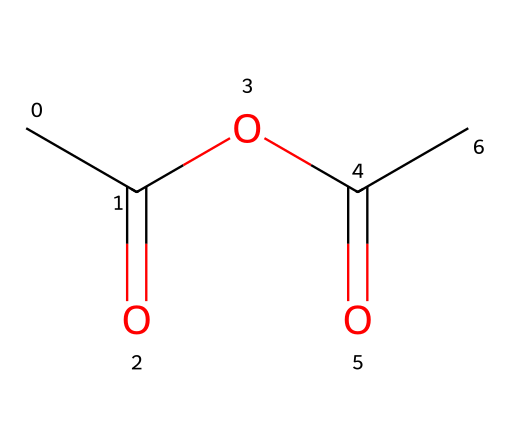How many carbon atoms are in this chemical structure? By examining the SMILES representation, there are four 'C' characters in the string, indicating there are four carbon atoms in total.
Answer: four What functional groups are present in acetic anhydride? Acetic anhydride contains two acyl groups derived from acetic acid, which is represented by the presence of two carbonyl (C=O) groups, alongside the oxygen atoms connecting them.
Answer: two acyl groups What is the total number of oxygen atoms in this compound? The SMILES notation includes two 'O' characters, indicating that there are two oxygen atoms in the molecule.
Answer: two What is the general classification of acetic anhydride based on its structure? Acetic anhydride is classified as an acid anhydride due to the presence of an anhydride linkage (the connection between two acyl groups via oxygen) in its structure.
Answer: acid anhydride What type of reaction can acetic anhydride undergo due to its structure? Acetic anhydride can participate in acylation reactions because it has reactive acyl groups that can react with nucleophiles, making it useful in organic synthesis.
Answer: acylation What is the significance of the carbonyl groups in acetic anhydride? The carbonyl groups (C=O) in the structure are significant as they play a critical role in its reactivity and ability to act as an electrophile in chemical reactions.
Answer: reactivity and electrophilicity 